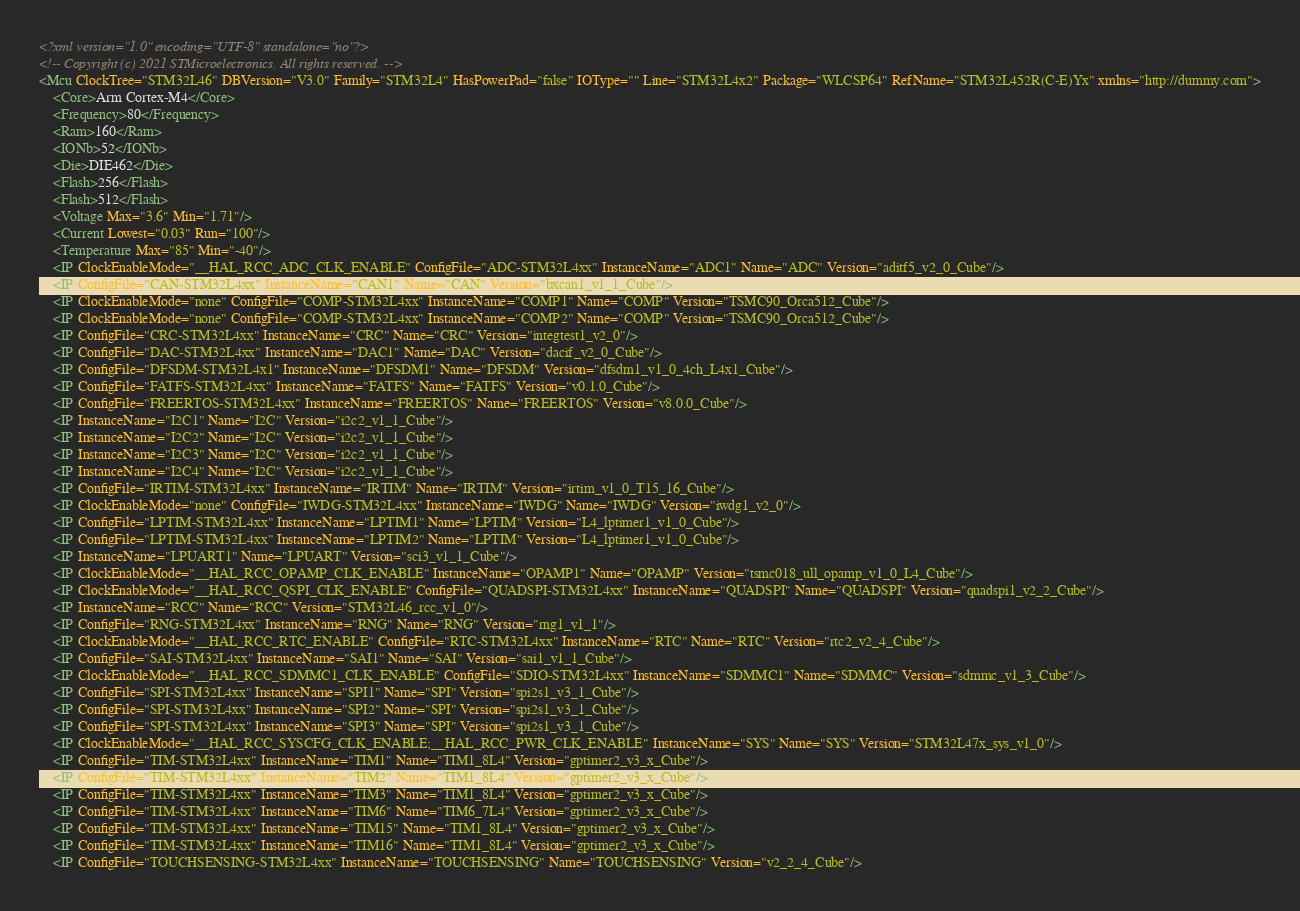<code> <loc_0><loc_0><loc_500><loc_500><_XML_><?xml version="1.0" encoding="UTF-8" standalone="no"?>
<!-- Copyright (c) 2021 STMicroelectronics. All rights reserved. -->
<Mcu ClockTree="STM32L46" DBVersion="V3.0" Family="STM32L4" HasPowerPad="false" IOType="" Line="STM32L4x2" Package="WLCSP64" RefName="STM32L452R(C-E)Yx" xmlns="http://dummy.com">
	<Core>Arm Cortex-M4</Core>
	<Frequency>80</Frequency>
	<Ram>160</Ram>
	<IONb>52</IONb>
	<Die>DIE462</Die>
	<Flash>256</Flash>
	<Flash>512</Flash>
	<Voltage Max="3.6" Min="1.71"/>
	<Current Lowest="0.03" Run="100"/>
	<Temperature Max="85" Min="-40"/>
	<IP ClockEnableMode="__HAL_RCC_ADC_CLK_ENABLE" ConfigFile="ADC-STM32L4xx" InstanceName="ADC1" Name="ADC" Version="aditf5_v2_0_Cube"/>
	<IP ConfigFile="CAN-STM32L4xx" InstanceName="CAN1" Name="CAN" Version="bxcan1_v1_1_Cube"/>
	<IP ClockEnableMode="none" ConfigFile="COMP-STM32L4xx" InstanceName="COMP1" Name="COMP" Version="TSMC90_Orca512_Cube"/>
	<IP ClockEnableMode="none" ConfigFile="COMP-STM32L4xx" InstanceName="COMP2" Name="COMP" Version="TSMC90_Orca512_Cube"/>
	<IP ConfigFile="CRC-STM32L4xx" InstanceName="CRC" Name="CRC" Version="integtest1_v2_0"/>
	<IP ConfigFile="DAC-STM32L4xx" InstanceName="DAC1" Name="DAC" Version="dacif_v2_0_Cube"/>
	<IP ConfigFile="DFSDM-STM32L4x1" InstanceName="DFSDM1" Name="DFSDM" Version="dfsdm1_v1_0_4ch_L4x1_Cube"/>
	<IP ConfigFile="FATFS-STM32L4xx" InstanceName="FATFS" Name="FATFS" Version="v0.1.0_Cube"/>
	<IP ConfigFile="FREERTOS-STM32L4xx" InstanceName="FREERTOS" Name="FREERTOS" Version="v8.0.0_Cube"/>
	<IP InstanceName="I2C1" Name="I2C" Version="i2c2_v1_1_Cube"/>
	<IP InstanceName="I2C2" Name="I2C" Version="i2c2_v1_1_Cube"/>
	<IP InstanceName="I2C3" Name="I2C" Version="i2c2_v1_1_Cube"/>
	<IP InstanceName="I2C4" Name="I2C" Version="i2c2_v1_1_Cube"/>
	<IP ConfigFile="IRTIM-STM32L4xx" InstanceName="IRTIM" Name="IRTIM" Version="irtim_v1_0_T15_16_Cube"/>
	<IP ClockEnableMode="none" ConfigFile="IWDG-STM32L4xx" InstanceName="IWDG" Name="IWDG" Version="iwdg1_v2_0"/>
	<IP ConfigFile="LPTIM-STM32L4xx" InstanceName="LPTIM1" Name="LPTIM" Version="L4_lptimer1_v1_0_Cube"/>
	<IP ConfigFile="LPTIM-STM32L4xx" InstanceName="LPTIM2" Name="LPTIM" Version="L4_lptimer1_v1_0_Cube"/>
	<IP InstanceName="LPUART1" Name="LPUART" Version="sci3_v1_1_Cube"/>
	<IP ClockEnableMode="__HAL_RCC_OPAMP_CLK_ENABLE" InstanceName="OPAMP1" Name="OPAMP" Version="tsmc018_ull_opamp_v1_0_L4_Cube"/>
	<IP ClockEnableMode="__HAL_RCC_QSPI_CLK_ENABLE" ConfigFile="QUADSPI-STM32L4xx" InstanceName="QUADSPI" Name="QUADSPI" Version="quadspi1_v2_2_Cube"/>
	<IP InstanceName="RCC" Name="RCC" Version="STM32L46_rcc_v1_0"/>
	<IP ConfigFile="RNG-STM32L4xx" InstanceName="RNG" Name="RNG" Version="rng1_v1_1"/>
	<IP ClockEnableMode="__HAL_RCC_RTC_ENABLE" ConfigFile="RTC-STM32L4xx" InstanceName="RTC" Name="RTC" Version="rtc2_v2_4_Cube"/>
	<IP ConfigFile="SAI-STM32L4xx" InstanceName="SAI1" Name="SAI" Version="sai1_v1_1_Cube"/>
	<IP ClockEnableMode="__HAL_RCC_SDMMC1_CLK_ENABLE" ConfigFile="SDIO-STM32L4xx" InstanceName="SDMMC1" Name="SDMMC" Version="sdmmc_v1_3_Cube"/>
	<IP ConfigFile="SPI-STM32L4xx" InstanceName="SPI1" Name="SPI" Version="spi2s1_v3_1_Cube"/>
	<IP ConfigFile="SPI-STM32L4xx" InstanceName="SPI2" Name="SPI" Version="spi2s1_v3_1_Cube"/>
	<IP ConfigFile="SPI-STM32L4xx" InstanceName="SPI3" Name="SPI" Version="spi2s1_v3_1_Cube"/>
	<IP ClockEnableMode="__HAL_RCC_SYSCFG_CLK_ENABLE;__HAL_RCC_PWR_CLK_ENABLE" InstanceName="SYS" Name="SYS" Version="STM32L47x_sys_v1_0"/>
	<IP ConfigFile="TIM-STM32L4xx" InstanceName="TIM1" Name="TIM1_8L4" Version="gptimer2_v3_x_Cube"/>
	<IP ConfigFile="TIM-STM32L4xx" InstanceName="TIM2" Name="TIM1_8L4" Version="gptimer2_v3_x_Cube"/>
	<IP ConfigFile="TIM-STM32L4xx" InstanceName="TIM3" Name="TIM1_8L4" Version="gptimer2_v3_x_Cube"/>
	<IP ConfigFile="TIM-STM32L4xx" InstanceName="TIM6" Name="TIM6_7L4" Version="gptimer2_v3_x_Cube"/>
	<IP ConfigFile="TIM-STM32L4xx" InstanceName="TIM15" Name="TIM1_8L4" Version="gptimer2_v3_x_Cube"/>
	<IP ConfigFile="TIM-STM32L4xx" InstanceName="TIM16" Name="TIM1_8L4" Version="gptimer2_v3_x_Cube"/>
	<IP ConfigFile="TOUCHSENSING-STM32L4xx" InstanceName="TOUCHSENSING" Name="TOUCHSENSING" Version="v2_2_4_Cube"/></code> 